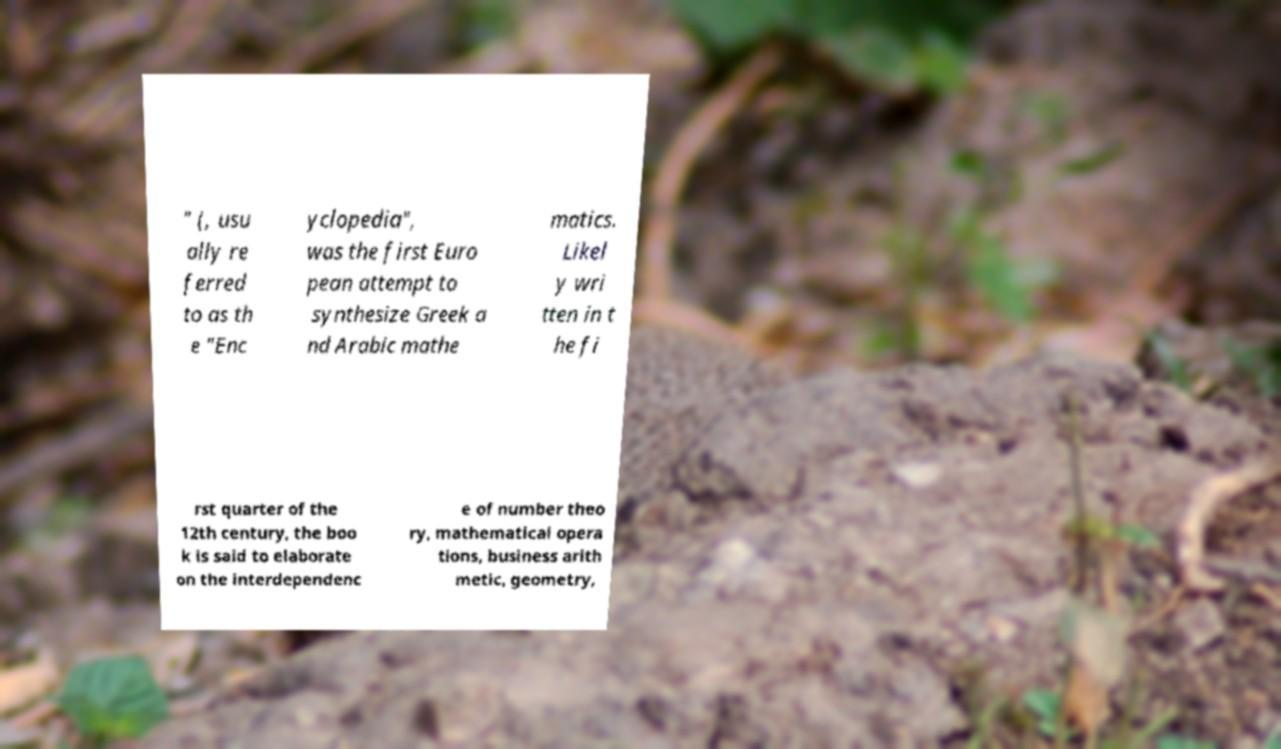What messages or text are displayed in this image? I need them in a readable, typed format. " (, usu ally re ferred to as th e "Enc yclopedia", was the first Euro pean attempt to synthesize Greek a nd Arabic mathe matics. Likel y wri tten in t he fi rst quarter of the 12th century, the boo k is said to elaborate on the interdependenc e of number theo ry, mathematical opera tions, business arith metic, geometry, 